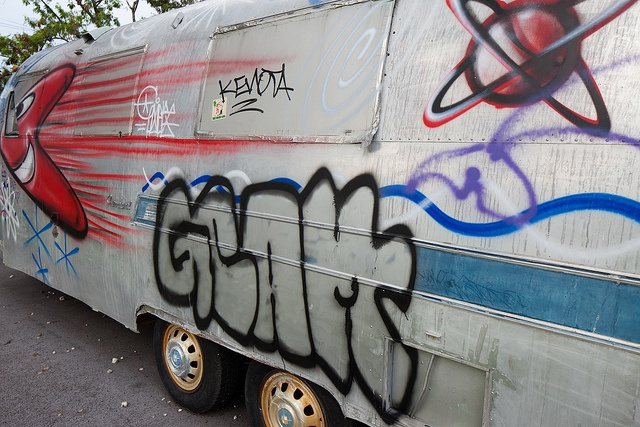Describe the objects in this image and their specific colors. I can see bus in darkgray, lightgray, gray, lavender, and black tones in this image. 